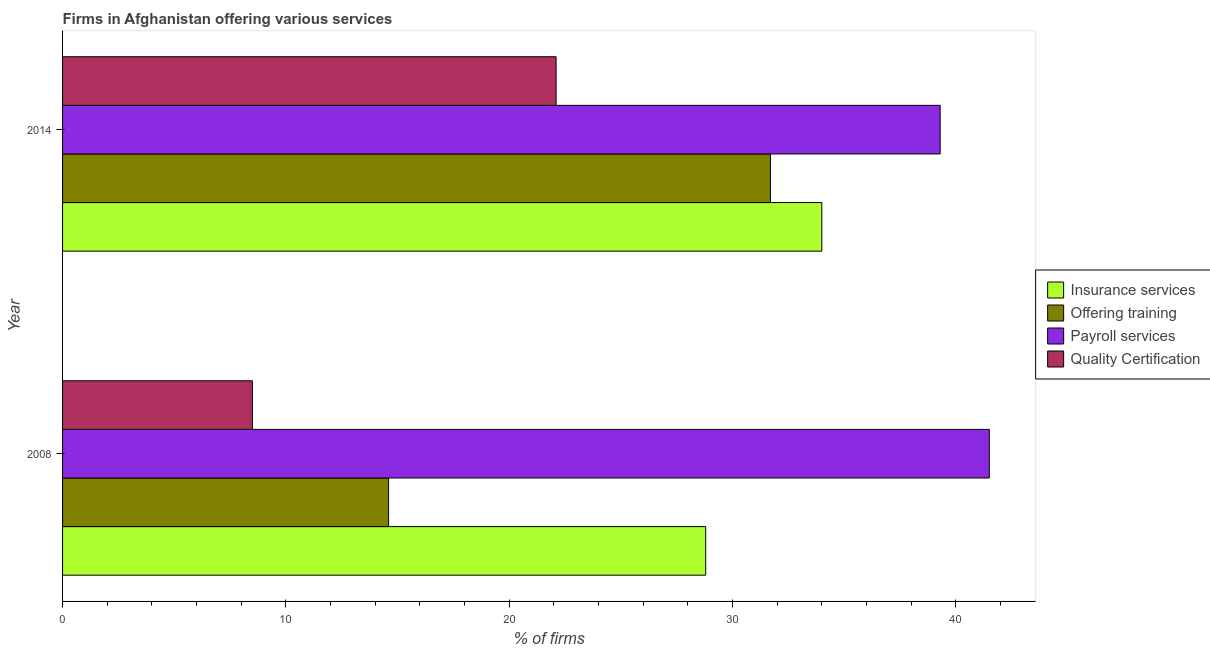How many groups of bars are there?
Provide a succinct answer. 2. Are the number of bars on each tick of the Y-axis equal?
Make the answer very short. Yes. In how many cases, is the number of bars for a given year not equal to the number of legend labels?
Provide a short and direct response. 0. What is the percentage of firms offering quality certification in 2014?
Keep it short and to the point. 22.1. Across all years, what is the maximum percentage of firms offering quality certification?
Ensure brevity in your answer.  22.1. Across all years, what is the minimum percentage of firms offering payroll services?
Make the answer very short. 39.3. In which year was the percentage of firms offering quality certification minimum?
Keep it short and to the point. 2008. What is the total percentage of firms offering quality certification in the graph?
Provide a short and direct response. 30.6. What is the difference between the percentage of firms offering training in 2008 and that in 2014?
Your response must be concise. -17.1. What is the difference between the percentage of firms offering insurance services in 2008 and the percentage of firms offering payroll services in 2014?
Make the answer very short. -10.5. What is the average percentage of firms offering insurance services per year?
Offer a terse response. 31.4. In the year 2014, what is the difference between the percentage of firms offering training and percentage of firms offering payroll services?
Your response must be concise. -7.6. What is the ratio of the percentage of firms offering insurance services in 2008 to that in 2014?
Offer a very short reply. 0.85. Is the percentage of firms offering quality certification in 2008 less than that in 2014?
Your response must be concise. Yes. In how many years, is the percentage of firms offering payroll services greater than the average percentage of firms offering payroll services taken over all years?
Your answer should be very brief. 1. Is it the case that in every year, the sum of the percentage of firms offering quality certification and percentage of firms offering insurance services is greater than the sum of percentage of firms offering training and percentage of firms offering payroll services?
Offer a terse response. Yes. What does the 4th bar from the top in 2008 represents?
Offer a very short reply. Insurance services. What does the 3rd bar from the bottom in 2014 represents?
Keep it short and to the point. Payroll services. Is it the case that in every year, the sum of the percentage of firms offering insurance services and percentage of firms offering training is greater than the percentage of firms offering payroll services?
Provide a succinct answer. Yes. How many bars are there?
Provide a short and direct response. 8. How many years are there in the graph?
Your answer should be compact. 2. Are the values on the major ticks of X-axis written in scientific E-notation?
Provide a succinct answer. No. Does the graph contain grids?
Provide a short and direct response. No. What is the title of the graph?
Provide a short and direct response. Firms in Afghanistan offering various services . What is the label or title of the X-axis?
Provide a succinct answer. % of firms. What is the % of firms of Insurance services in 2008?
Your answer should be very brief. 28.8. What is the % of firms of Offering training in 2008?
Make the answer very short. 14.6. What is the % of firms in Payroll services in 2008?
Your answer should be compact. 41.5. What is the % of firms of Quality Certification in 2008?
Your answer should be compact. 8.5. What is the % of firms in Insurance services in 2014?
Your response must be concise. 34. What is the % of firms in Offering training in 2014?
Provide a succinct answer. 31.7. What is the % of firms in Payroll services in 2014?
Give a very brief answer. 39.3. What is the % of firms in Quality Certification in 2014?
Your answer should be compact. 22.1. Across all years, what is the maximum % of firms in Offering training?
Your answer should be compact. 31.7. Across all years, what is the maximum % of firms of Payroll services?
Keep it short and to the point. 41.5. Across all years, what is the maximum % of firms in Quality Certification?
Give a very brief answer. 22.1. Across all years, what is the minimum % of firms in Insurance services?
Your answer should be very brief. 28.8. Across all years, what is the minimum % of firms in Offering training?
Your answer should be compact. 14.6. Across all years, what is the minimum % of firms in Payroll services?
Ensure brevity in your answer.  39.3. Across all years, what is the minimum % of firms in Quality Certification?
Provide a succinct answer. 8.5. What is the total % of firms of Insurance services in the graph?
Offer a very short reply. 62.8. What is the total % of firms of Offering training in the graph?
Offer a very short reply. 46.3. What is the total % of firms of Payroll services in the graph?
Your answer should be very brief. 80.8. What is the total % of firms in Quality Certification in the graph?
Keep it short and to the point. 30.6. What is the difference between the % of firms in Offering training in 2008 and that in 2014?
Offer a very short reply. -17.1. What is the difference between the % of firms in Offering training in 2008 and the % of firms in Payroll services in 2014?
Your answer should be compact. -24.7. What is the difference between the % of firms in Offering training in 2008 and the % of firms in Quality Certification in 2014?
Make the answer very short. -7.5. What is the average % of firms in Insurance services per year?
Provide a succinct answer. 31.4. What is the average % of firms of Offering training per year?
Provide a succinct answer. 23.15. What is the average % of firms in Payroll services per year?
Your response must be concise. 40.4. What is the average % of firms in Quality Certification per year?
Offer a terse response. 15.3. In the year 2008, what is the difference between the % of firms in Insurance services and % of firms in Offering training?
Your response must be concise. 14.2. In the year 2008, what is the difference between the % of firms in Insurance services and % of firms in Quality Certification?
Offer a terse response. 20.3. In the year 2008, what is the difference between the % of firms of Offering training and % of firms of Payroll services?
Provide a short and direct response. -26.9. In the year 2008, what is the difference between the % of firms of Offering training and % of firms of Quality Certification?
Your answer should be compact. 6.1. In the year 2008, what is the difference between the % of firms of Payroll services and % of firms of Quality Certification?
Your response must be concise. 33. In the year 2014, what is the difference between the % of firms in Insurance services and % of firms in Offering training?
Give a very brief answer. 2.3. In the year 2014, what is the difference between the % of firms of Insurance services and % of firms of Quality Certification?
Offer a very short reply. 11.9. In the year 2014, what is the difference between the % of firms in Offering training and % of firms in Payroll services?
Provide a short and direct response. -7.6. What is the ratio of the % of firms of Insurance services in 2008 to that in 2014?
Keep it short and to the point. 0.85. What is the ratio of the % of firms of Offering training in 2008 to that in 2014?
Your answer should be compact. 0.46. What is the ratio of the % of firms in Payroll services in 2008 to that in 2014?
Provide a short and direct response. 1.06. What is the ratio of the % of firms in Quality Certification in 2008 to that in 2014?
Your response must be concise. 0.38. What is the difference between the highest and the second highest % of firms in Offering training?
Offer a very short reply. 17.1. What is the difference between the highest and the second highest % of firms in Payroll services?
Your response must be concise. 2.2. What is the difference between the highest and the lowest % of firms of Offering training?
Provide a succinct answer. 17.1. 